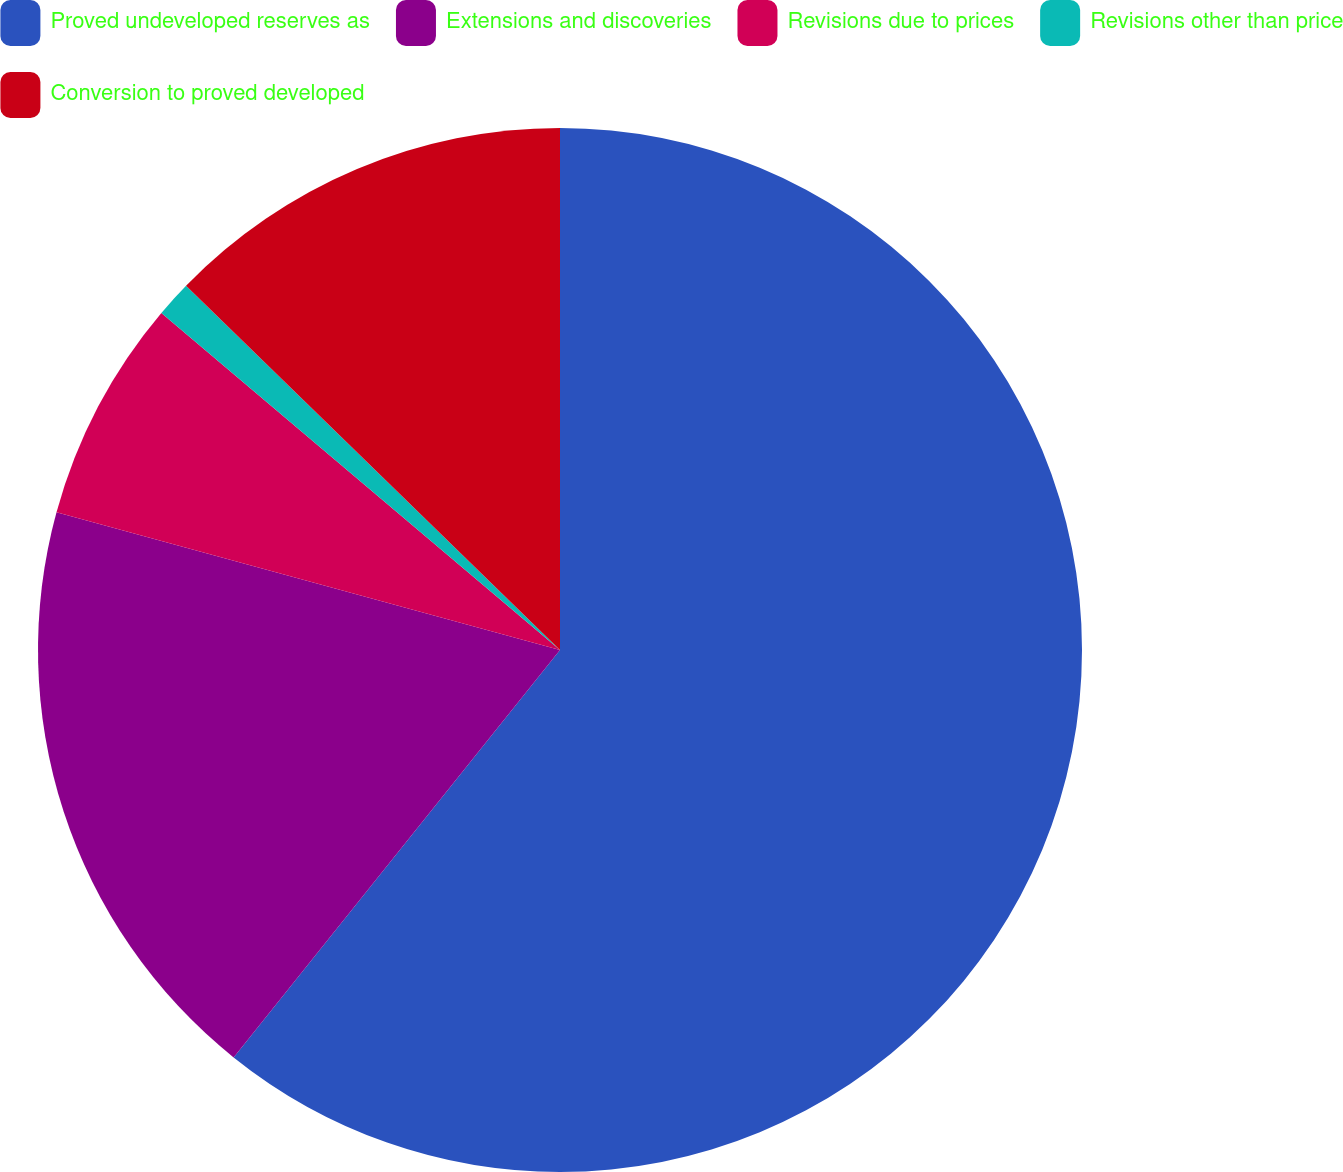<chart> <loc_0><loc_0><loc_500><loc_500><pie_chart><fcel>Proved undeveloped reserves as<fcel>Extensions and discoveries<fcel>Revisions due to prices<fcel>Revisions other than price<fcel>Conversion to proved developed<nl><fcel>60.75%<fcel>18.5%<fcel>6.92%<fcel>1.12%<fcel>12.71%<nl></chart> 